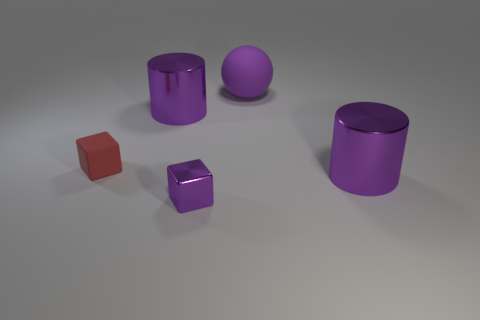Add 3 small purple objects. How many objects exist? 8 Subtract all cubes. How many objects are left? 3 Subtract 0 blue cubes. How many objects are left? 5 Subtract all tiny red matte objects. Subtract all big purple objects. How many objects are left? 1 Add 1 metallic cylinders. How many metallic cylinders are left? 3 Add 5 big metallic things. How many big metallic things exist? 7 